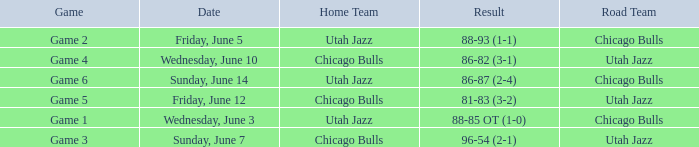Result of 86-87 (2-4) is what game? Game 6. 